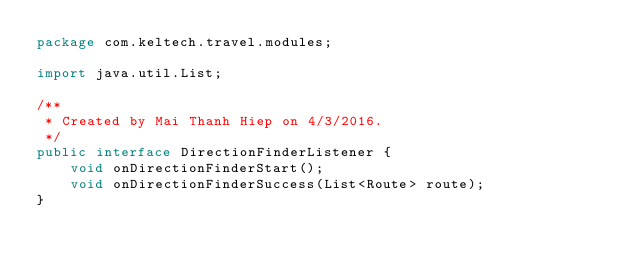Convert code to text. <code><loc_0><loc_0><loc_500><loc_500><_Java_>package com.keltech.travel.modules;

import java.util.List;

/**
 * Created by Mai Thanh Hiep on 4/3/2016.
 */
public interface DirectionFinderListener {
    void onDirectionFinderStart();
    void onDirectionFinderSuccess(List<Route> route);
}
</code> 